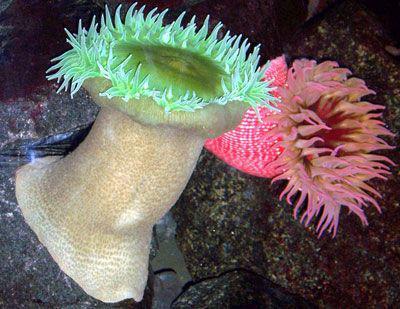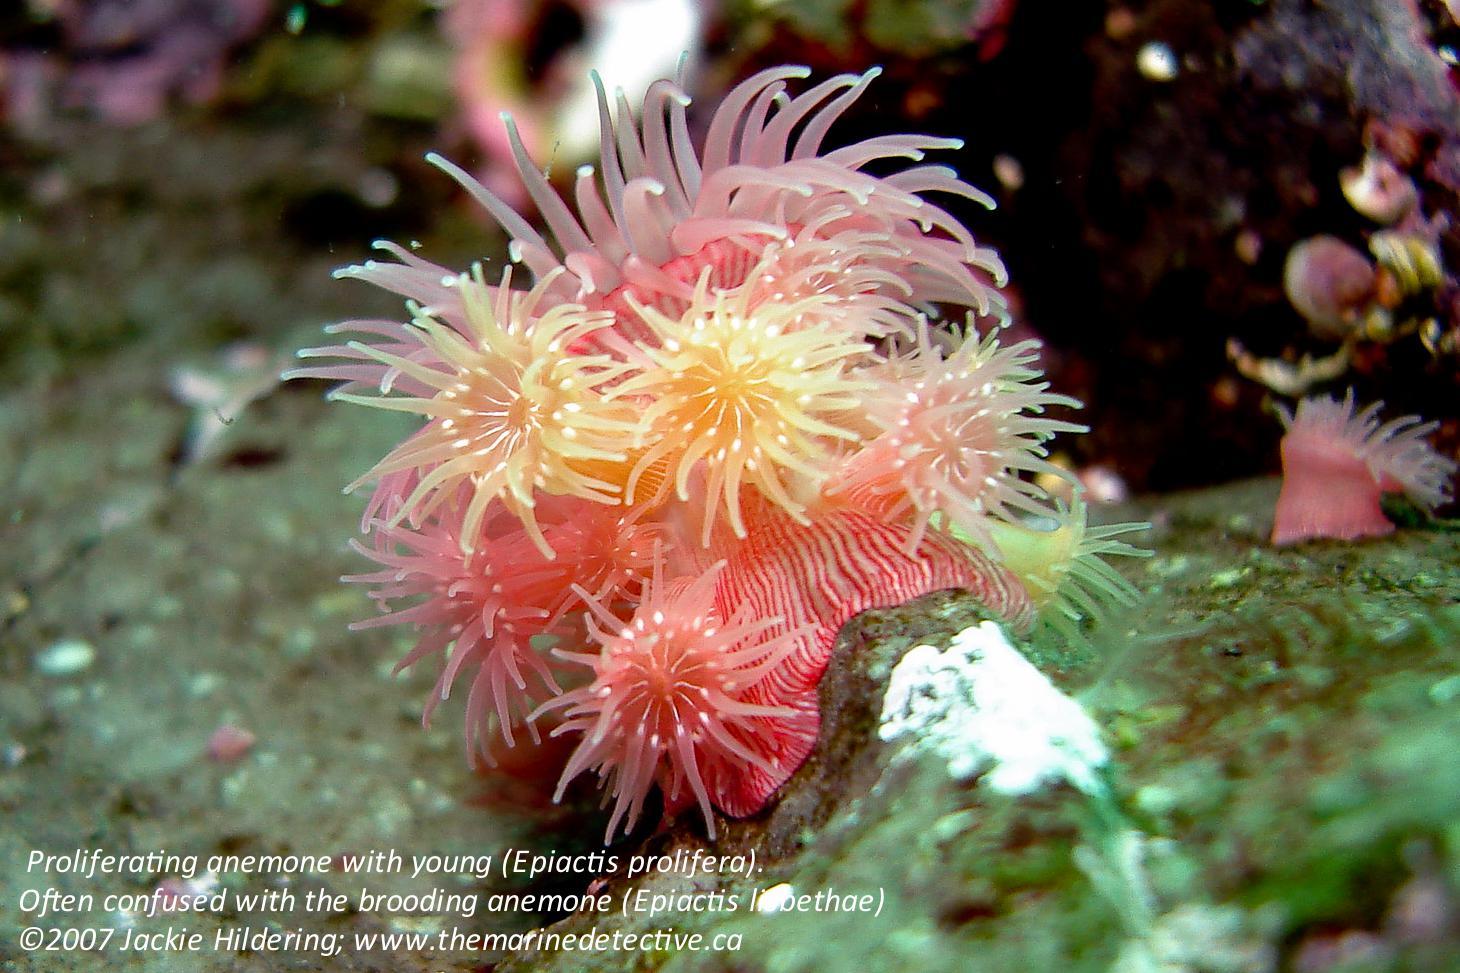The first image is the image on the left, the second image is the image on the right. Examine the images to the left and right. Is the description "there are 2 fish swimming near the anenome" accurate? Answer yes or no. No. The first image is the image on the left, the second image is the image on the right. Given the left and right images, does the statement "In one image, there is at least one fish swimming in or near the sea anemone" hold true? Answer yes or no. No. 